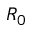Convert formula to latex. <formula><loc_0><loc_0><loc_500><loc_500>R _ { 0 }</formula> 